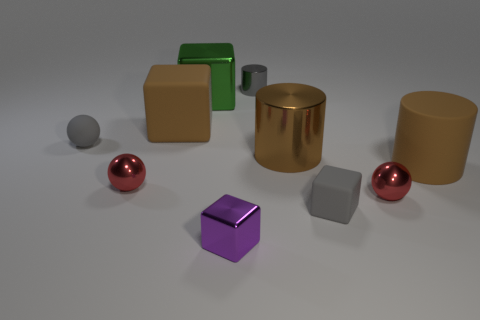Does the purple cube have the same size as the matte sphere?
Give a very brief answer. Yes. How many other objects are the same size as the brown rubber cube?
Offer a terse response. 3. Is the color of the small rubber ball the same as the small matte cube?
Your response must be concise. Yes. There is a tiny red metallic thing to the left of the big green shiny cube on the left side of the big cylinder to the right of the small gray block; what is its shape?
Give a very brief answer. Sphere. How many things are either blocks that are behind the small purple cube or large shiny things that are in front of the big green block?
Your answer should be very brief. 4. What size is the brown cylinder left of the large brown rubber thing to the right of the purple metal block?
Ensure brevity in your answer.  Large. Does the cylinder that is behind the brown block have the same color as the tiny rubber ball?
Keep it short and to the point. Yes. Is there a tiny gray object of the same shape as the tiny purple object?
Offer a very short reply. Yes. What is the color of the rubber thing that is the same size as the gray rubber ball?
Offer a terse response. Gray. There is a red metallic thing that is to the right of the tiny purple metallic thing; what is its size?
Your answer should be compact. Small. 